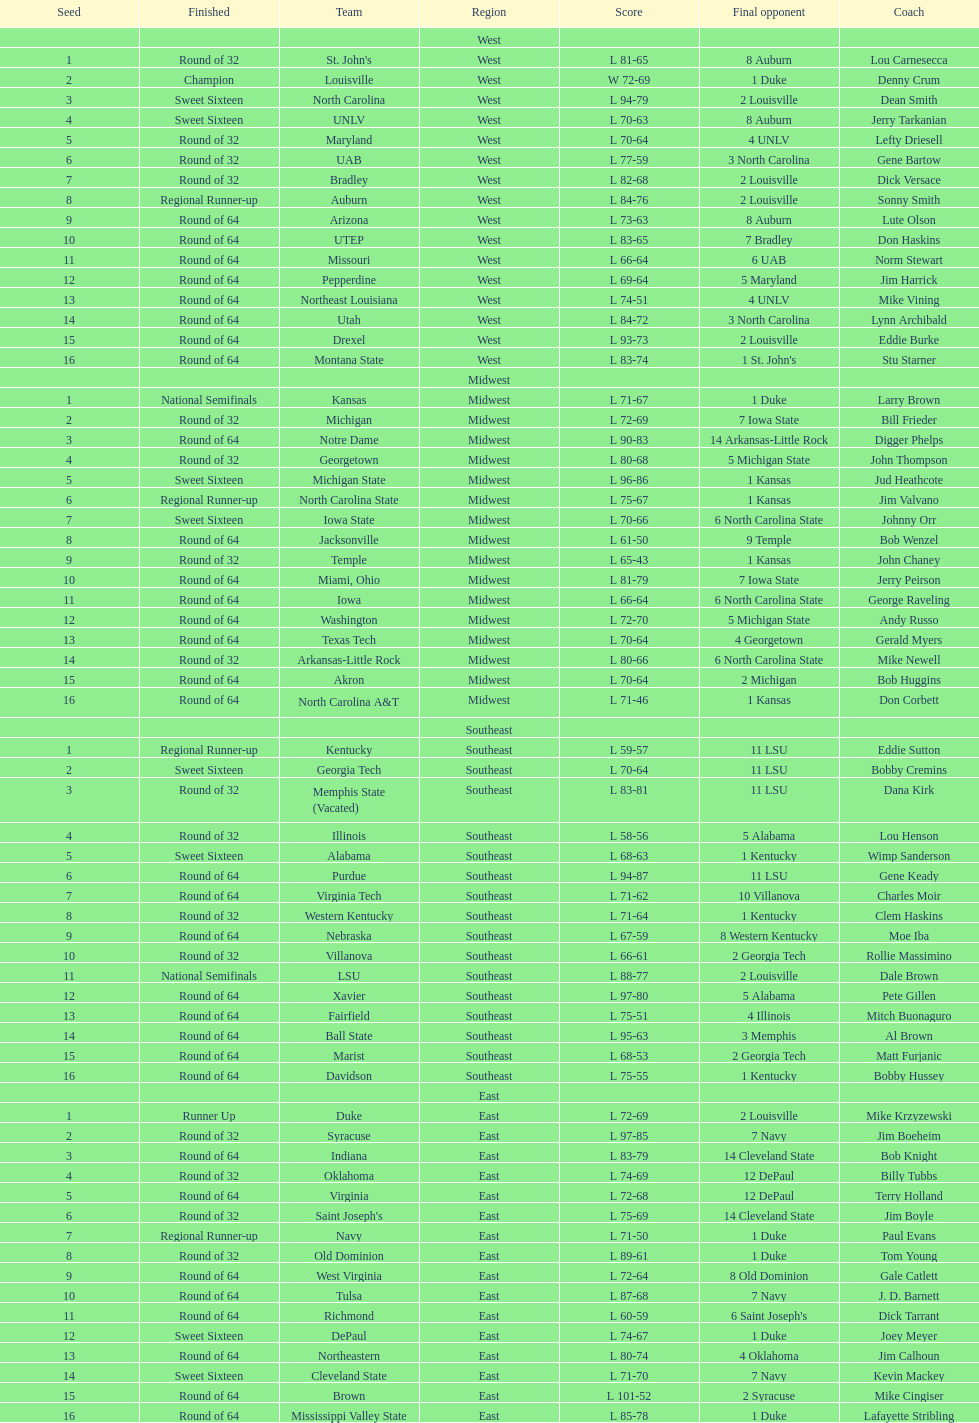How many teams are in the east region. 16. Can you parse all the data within this table? {'header': ['Seed', 'Finished', 'Team', 'Region', 'Score', 'Final opponent', 'Coach'], 'rows': [['', '', '', 'West', '', '', ''], ['1', 'Round of 32', "St. John's", 'West', 'L 81-65', '8 Auburn', 'Lou Carnesecca'], ['2', 'Champion', 'Louisville', 'West', 'W 72-69', '1 Duke', 'Denny Crum'], ['3', 'Sweet Sixteen', 'North Carolina', 'West', 'L 94-79', '2 Louisville', 'Dean Smith'], ['4', 'Sweet Sixteen', 'UNLV', 'West', 'L 70-63', '8 Auburn', 'Jerry Tarkanian'], ['5', 'Round of 32', 'Maryland', 'West', 'L 70-64', '4 UNLV', 'Lefty Driesell'], ['6', 'Round of 32', 'UAB', 'West', 'L 77-59', '3 North Carolina', 'Gene Bartow'], ['7', 'Round of 32', 'Bradley', 'West', 'L 82-68', '2 Louisville', 'Dick Versace'], ['8', 'Regional Runner-up', 'Auburn', 'West', 'L 84-76', '2 Louisville', 'Sonny Smith'], ['9', 'Round of 64', 'Arizona', 'West', 'L 73-63', '8 Auburn', 'Lute Olson'], ['10', 'Round of 64', 'UTEP', 'West', 'L 83-65', '7 Bradley', 'Don Haskins'], ['11', 'Round of 64', 'Missouri', 'West', 'L 66-64', '6 UAB', 'Norm Stewart'], ['12', 'Round of 64', 'Pepperdine', 'West', 'L 69-64', '5 Maryland', 'Jim Harrick'], ['13', 'Round of 64', 'Northeast Louisiana', 'West', 'L 74-51', '4 UNLV', 'Mike Vining'], ['14', 'Round of 64', 'Utah', 'West', 'L 84-72', '3 North Carolina', 'Lynn Archibald'], ['15', 'Round of 64', 'Drexel', 'West', 'L 93-73', '2 Louisville', 'Eddie Burke'], ['16', 'Round of 64', 'Montana State', 'West', 'L 83-74', "1 St. John's", 'Stu Starner'], ['', '', '', 'Midwest', '', '', ''], ['1', 'National Semifinals', 'Kansas', 'Midwest', 'L 71-67', '1 Duke', 'Larry Brown'], ['2', 'Round of 32', 'Michigan', 'Midwest', 'L 72-69', '7 Iowa State', 'Bill Frieder'], ['3', 'Round of 64', 'Notre Dame', 'Midwest', 'L 90-83', '14 Arkansas-Little Rock', 'Digger Phelps'], ['4', 'Round of 32', 'Georgetown', 'Midwest', 'L 80-68', '5 Michigan State', 'John Thompson'], ['5', 'Sweet Sixteen', 'Michigan State', 'Midwest', 'L 96-86', '1 Kansas', 'Jud Heathcote'], ['6', 'Regional Runner-up', 'North Carolina State', 'Midwest', 'L 75-67', '1 Kansas', 'Jim Valvano'], ['7', 'Sweet Sixteen', 'Iowa State', 'Midwest', 'L 70-66', '6 North Carolina State', 'Johnny Orr'], ['8', 'Round of 64', 'Jacksonville', 'Midwest', 'L 61-50', '9 Temple', 'Bob Wenzel'], ['9', 'Round of 32', 'Temple', 'Midwest', 'L 65-43', '1 Kansas', 'John Chaney'], ['10', 'Round of 64', 'Miami, Ohio', 'Midwest', 'L 81-79', '7 Iowa State', 'Jerry Peirson'], ['11', 'Round of 64', 'Iowa', 'Midwest', 'L 66-64', '6 North Carolina State', 'George Raveling'], ['12', 'Round of 64', 'Washington', 'Midwest', 'L 72-70', '5 Michigan State', 'Andy Russo'], ['13', 'Round of 64', 'Texas Tech', 'Midwest', 'L 70-64', '4 Georgetown', 'Gerald Myers'], ['14', 'Round of 32', 'Arkansas-Little Rock', 'Midwest', 'L 80-66', '6 North Carolina State', 'Mike Newell'], ['15', 'Round of 64', 'Akron', 'Midwest', 'L 70-64', '2 Michigan', 'Bob Huggins'], ['16', 'Round of 64', 'North Carolina A&T', 'Midwest', 'L 71-46', '1 Kansas', 'Don Corbett'], ['', '', '', 'Southeast', '', '', ''], ['1', 'Regional Runner-up', 'Kentucky', 'Southeast', 'L 59-57', '11 LSU', 'Eddie Sutton'], ['2', 'Sweet Sixteen', 'Georgia Tech', 'Southeast', 'L 70-64', '11 LSU', 'Bobby Cremins'], ['3', 'Round of 32', 'Memphis State (Vacated)', 'Southeast', 'L 83-81', '11 LSU', 'Dana Kirk'], ['4', 'Round of 32', 'Illinois', 'Southeast', 'L 58-56', '5 Alabama', 'Lou Henson'], ['5', 'Sweet Sixteen', 'Alabama', 'Southeast', 'L 68-63', '1 Kentucky', 'Wimp Sanderson'], ['6', 'Round of 64', 'Purdue', 'Southeast', 'L 94-87', '11 LSU', 'Gene Keady'], ['7', 'Round of 64', 'Virginia Tech', 'Southeast', 'L 71-62', '10 Villanova', 'Charles Moir'], ['8', 'Round of 32', 'Western Kentucky', 'Southeast', 'L 71-64', '1 Kentucky', 'Clem Haskins'], ['9', 'Round of 64', 'Nebraska', 'Southeast', 'L 67-59', '8 Western Kentucky', 'Moe Iba'], ['10', 'Round of 32', 'Villanova', 'Southeast', 'L 66-61', '2 Georgia Tech', 'Rollie Massimino'], ['11', 'National Semifinals', 'LSU', 'Southeast', 'L 88-77', '2 Louisville', 'Dale Brown'], ['12', 'Round of 64', 'Xavier', 'Southeast', 'L 97-80', '5 Alabama', 'Pete Gillen'], ['13', 'Round of 64', 'Fairfield', 'Southeast', 'L 75-51', '4 Illinois', 'Mitch Buonaguro'], ['14', 'Round of 64', 'Ball State', 'Southeast', 'L 95-63', '3 Memphis', 'Al Brown'], ['15', 'Round of 64', 'Marist', 'Southeast', 'L 68-53', '2 Georgia Tech', 'Matt Furjanic'], ['16', 'Round of 64', 'Davidson', 'Southeast', 'L 75-55', '1 Kentucky', 'Bobby Hussey'], ['', '', '', 'East', '', '', ''], ['1', 'Runner Up', 'Duke', 'East', 'L 72-69', '2 Louisville', 'Mike Krzyzewski'], ['2', 'Round of 32', 'Syracuse', 'East', 'L 97-85', '7 Navy', 'Jim Boeheim'], ['3', 'Round of 64', 'Indiana', 'East', 'L 83-79', '14 Cleveland State', 'Bob Knight'], ['4', 'Round of 32', 'Oklahoma', 'East', 'L 74-69', '12 DePaul', 'Billy Tubbs'], ['5', 'Round of 64', 'Virginia', 'East', 'L 72-68', '12 DePaul', 'Terry Holland'], ['6', 'Round of 32', "Saint Joseph's", 'East', 'L 75-69', '14 Cleveland State', 'Jim Boyle'], ['7', 'Regional Runner-up', 'Navy', 'East', 'L 71-50', '1 Duke', 'Paul Evans'], ['8', 'Round of 32', 'Old Dominion', 'East', 'L 89-61', '1 Duke', 'Tom Young'], ['9', 'Round of 64', 'West Virginia', 'East', 'L 72-64', '8 Old Dominion', 'Gale Catlett'], ['10', 'Round of 64', 'Tulsa', 'East', 'L 87-68', '7 Navy', 'J. D. Barnett'], ['11', 'Round of 64', 'Richmond', 'East', 'L 60-59', "6 Saint Joseph's", 'Dick Tarrant'], ['12', 'Sweet Sixteen', 'DePaul', 'East', 'L 74-67', '1 Duke', 'Joey Meyer'], ['13', 'Round of 64', 'Northeastern', 'East', 'L 80-74', '4 Oklahoma', 'Jim Calhoun'], ['14', 'Sweet Sixteen', 'Cleveland State', 'East', 'L 71-70', '7 Navy', 'Kevin Mackey'], ['15', 'Round of 64', 'Brown', 'East', 'L 101-52', '2 Syracuse', 'Mike Cingiser'], ['16', 'Round of 64', 'Mississippi Valley State', 'East', 'L 85-78', '1 Duke', 'Lafayette Stribling']]} 